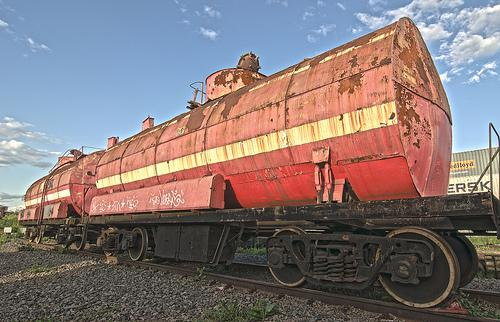Question: why is the train stopped?
Choices:
A. Broken down.
B. Picking up passengers.
C. Shut down for the night.
D. Loading cargo.
Answer with the letter. Answer: A Question: what is behind the train?
Choices:
A. People.
B. The station.
C. A sign.
D. Mountains.
Answer with the letter. Answer: C Question: why is the train rusted?
Choices:
A. It's been in the rain.
B. It's old.
C. It hasn't been kept well.
D. People scraped at the paint.
Answer with the letter. Answer: B 